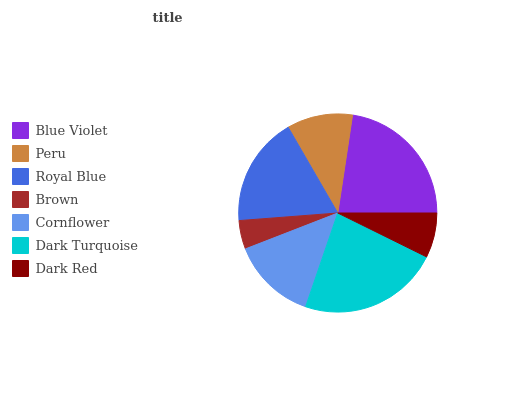Is Brown the minimum?
Answer yes or no. Yes. Is Dark Turquoise the maximum?
Answer yes or no. Yes. Is Peru the minimum?
Answer yes or no. No. Is Peru the maximum?
Answer yes or no. No. Is Blue Violet greater than Peru?
Answer yes or no. Yes. Is Peru less than Blue Violet?
Answer yes or no. Yes. Is Peru greater than Blue Violet?
Answer yes or no. No. Is Blue Violet less than Peru?
Answer yes or no. No. Is Cornflower the high median?
Answer yes or no. Yes. Is Cornflower the low median?
Answer yes or no. Yes. Is Royal Blue the high median?
Answer yes or no. No. Is Dark Turquoise the low median?
Answer yes or no. No. 